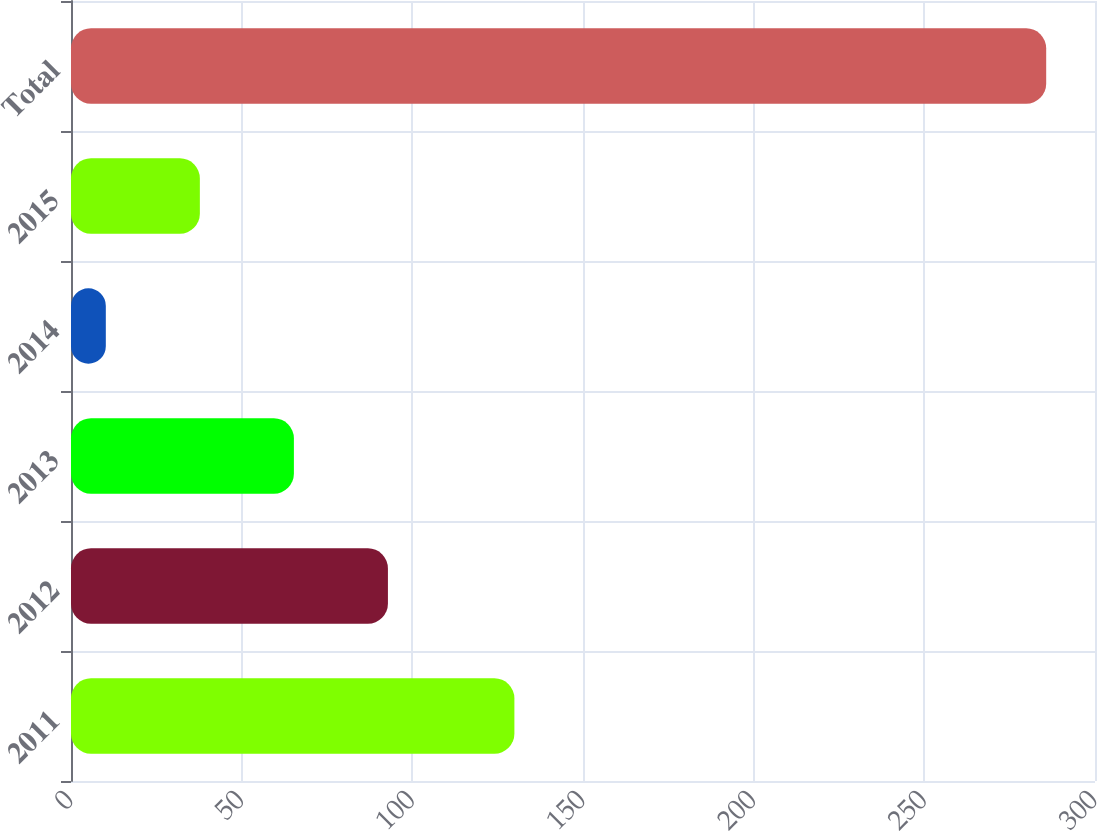<chart> <loc_0><loc_0><loc_500><loc_500><bar_chart><fcel>2011<fcel>2012<fcel>2013<fcel>2014<fcel>2015<fcel>Total<nl><fcel>129.9<fcel>92.85<fcel>65.3<fcel>10.2<fcel>37.75<fcel>285.7<nl></chart> 